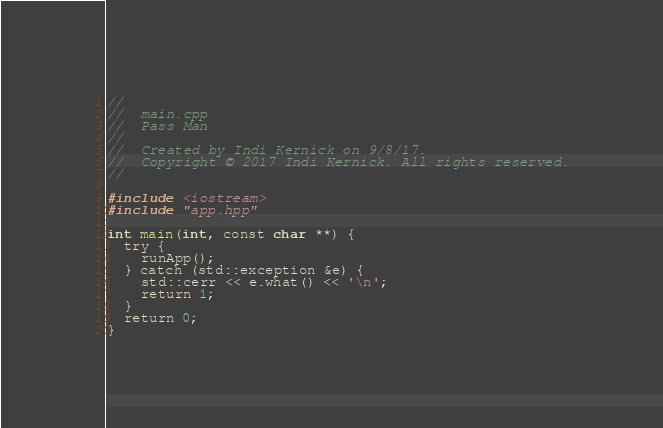Convert code to text. <code><loc_0><loc_0><loc_500><loc_500><_C++_>//
//  main.cpp
//  Pass Man
//
//  Created by Indi Kernick on 9/8/17.
//  Copyright © 2017 Indi Kernick. All rights reserved.
//

#include <iostream>
#include "app.hpp"

int main(int, const char **) {
  try {
    runApp();
  } catch (std::exception &e) {
    std::cerr << e.what() << '\n';
    return 1;
  }
  return 0;
}
</code> 